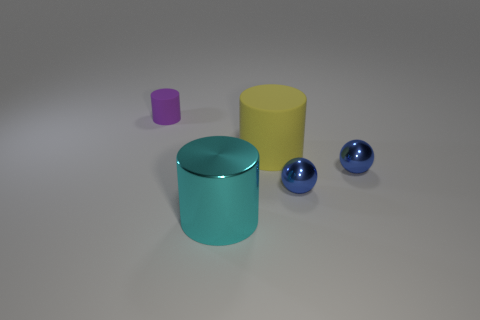There is a big object in front of the big matte cylinder; is it the same shape as the small thing that is behind the large matte thing?
Keep it short and to the point. Yes. How many big cyan metal objects are in front of the rubber cylinder on the right side of the matte object that is behind the big yellow matte object?
Your response must be concise. 1. What color is the tiny rubber object?
Give a very brief answer. Purple. How many other objects are there of the same size as the cyan metallic object?
Keep it short and to the point. 1. There is a cyan object that is the same shape as the purple thing; what is its material?
Offer a terse response. Metal. What material is the cyan cylinder to the left of the matte cylinder in front of the rubber cylinder left of the big yellow object?
Your answer should be very brief. Metal. What size is the purple object that is the same material as the large yellow thing?
Your answer should be compact. Small. Are there any other things that have the same color as the big shiny cylinder?
Provide a succinct answer. No. There is a rubber cylinder that is in front of the tiny cylinder; does it have the same color as the large object in front of the large yellow matte cylinder?
Your answer should be very brief. No. There is a big thing on the left side of the big yellow cylinder; what is its color?
Give a very brief answer. Cyan. 